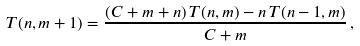Convert formula to latex. <formula><loc_0><loc_0><loc_500><loc_500>T ( n , m + 1 ) = \frac { ( C + m + n ) \, T ( n , m ) - n \, T ( n - 1 , m ) } { C + m } \, ,</formula> 